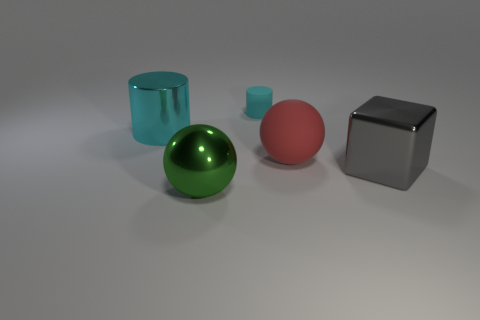Add 4 small matte objects. How many objects exist? 9 Subtract all blocks. How many objects are left? 4 Subtract 0 brown cylinders. How many objects are left? 5 Subtract all big red objects. Subtract all small yellow rubber balls. How many objects are left? 4 Add 3 big green things. How many big green things are left? 4 Add 1 large red matte balls. How many large red matte balls exist? 2 